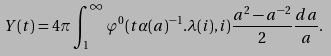Convert formula to latex. <formula><loc_0><loc_0><loc_500><loc_500>Y ( t ) = 4 \pi \int _ { 1 } ^ { \infty } \varphi ^ { 0 } ( t \alpha ( a ) ^ { - 1 } . \lambda ( i ) , i ) \frac { a ^ { 2 } - a ^ { - 2 } } { 2 } \frac { d a } { a } .</formula> 